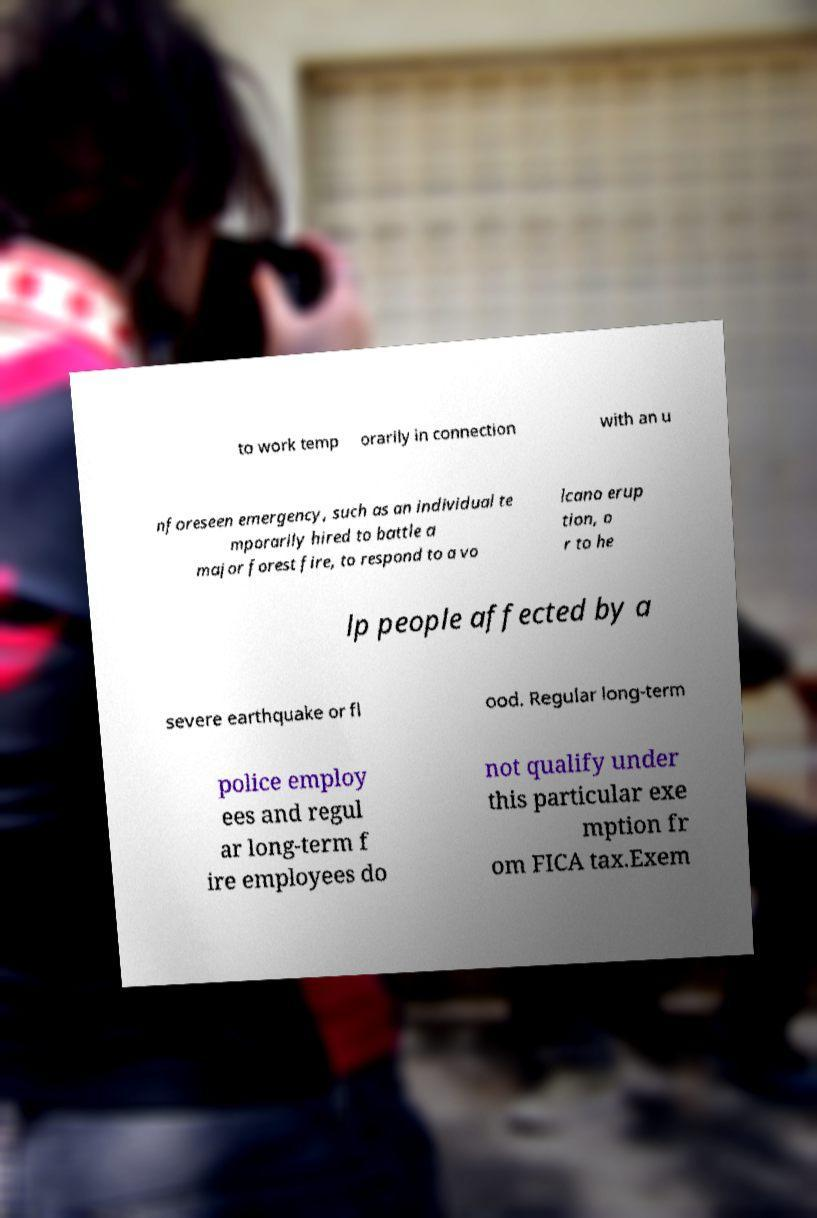Could you extract and type out the text from this image? to work temp orarily in connection with an u nforeseen emergency, such as an individual te mporarily hired to battle a major forest fire, to respond to a vo lcano erup tion, o r to he lp people affected by a severe earthquake or fl ood. Regular long-term police employ ees and regul ar long-term f ire employees do not qualify under this particular exe mption fr om FICA tax.Exem 